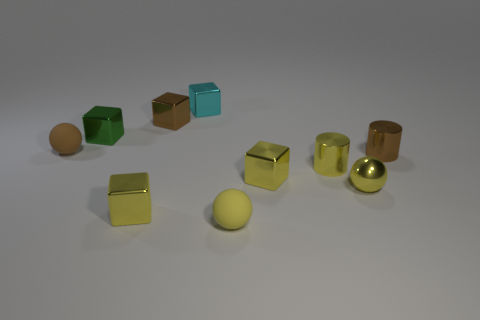What material is the tiny block that is in front of the small green metallic block and on the left side of the tiny yellow matte ball?
Make the answer very short. Metal. Is there anything else that has the same color as the shiny sphere?
Give a very brief answer. Yes. Is the number of brown shiny cylinders in front of the tiny yellow matte sphere less than the number of large brown rubber cubes?
Give a very brief answer. No. Are there more large yellow balls than small cyan metallic things?
Keep it short and to the point. No. Is there a metal object left of the small brown thing that is in front of the rubber object behind the yellow metallic ball?
Offer a terse response. Yes. How many other objects are there of the same size as the green thing?
Your answer should be very brief. 9. Are there any shiny things behind the brown cube?
Give a very brief answer. Yes. Do the small metallic ball and the matte ball that is right of the cyan shiny cube have the same color?
Your answer should be compact. Yes. There is a tiny rubber ball behind the small matte thing in front of the small rubber ball that is on the left side of the tiny cyan block; what color is it?
Your answer should be compact. Brown. Are there any big gray metallic objects that have the same shape as the cyan object?
Give a very brief answer. No. 